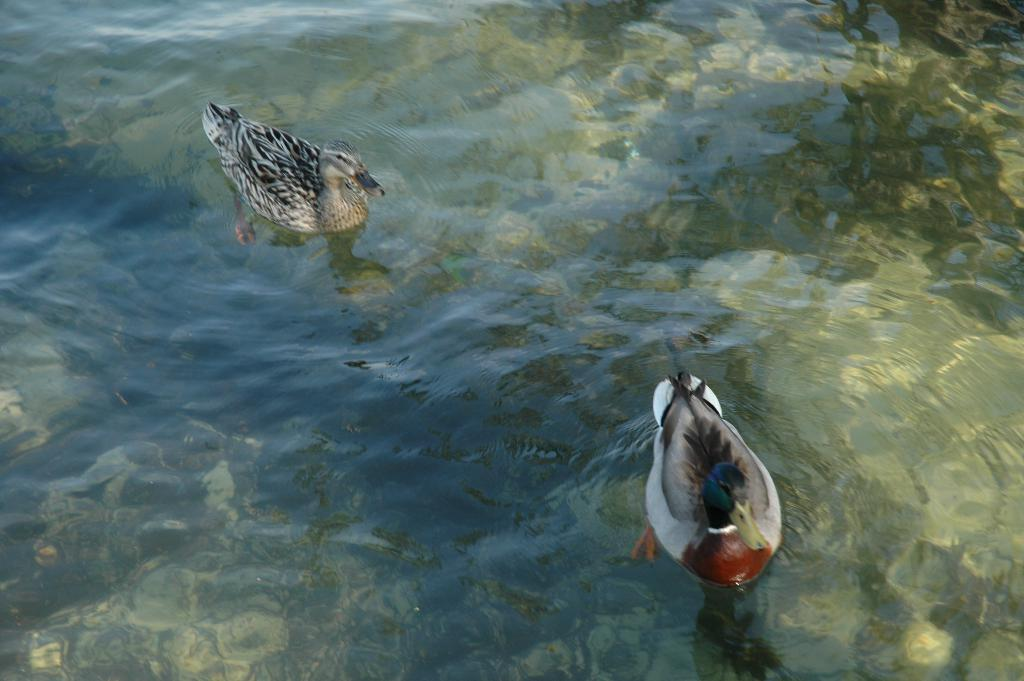What is the primary element visible in the image? There is water in the image. What type of animals can be seen in the water? There are ducks in the water. What type of spark can be seen coming from the ducks in the image? There is no spark present in the image; it features water and ducks. What insect is sitting on the duck's head in the image? There is no insect present in the image; it only features water and ducks. 